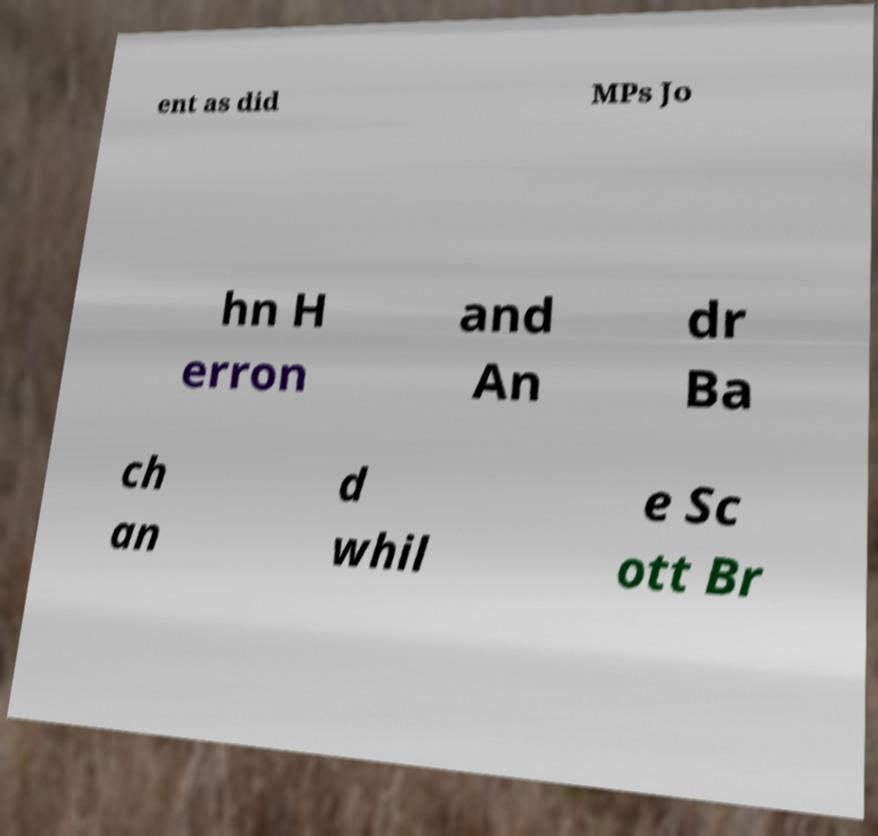What messages or text are displayed in this image? I need them in a readable, typed format. ent as did MPs Jo hn H erron and An dr Ba ch an d whil e Sc ott Br 